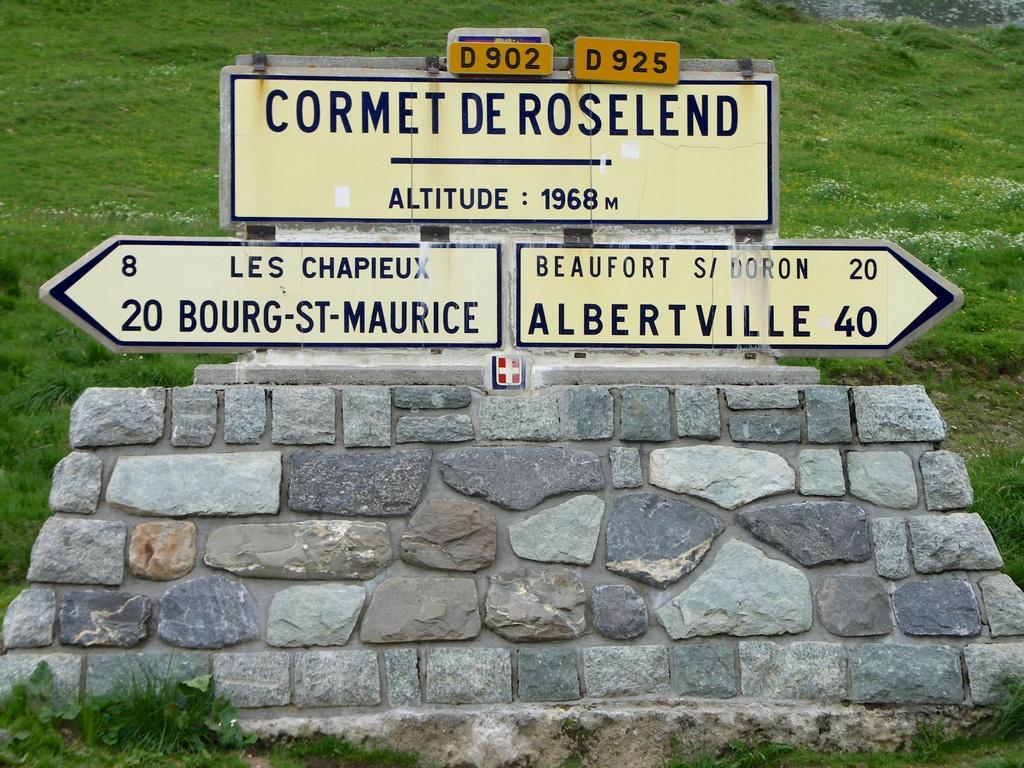<image>
Create a compact narrative representing the image presented. The altitude of Cormet De Roselend is 1968 meters. 